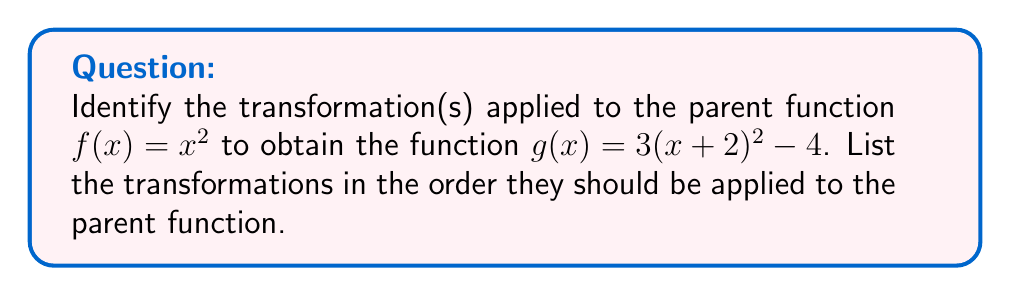Help me with this question. To identify the transformations applied to the parent function $f(x) = x^2$, we need to analyze the given function $g(x) = 3(x + 2)^2 - 4$ step by step:

1. First, let's rewrite the function in a standard form:
   $g(x) = 3(x + 2)^2 - 4$

2. Now, let's identify each transformation:

   a) Inside the parentheses, we see $(x + 2)$. This represents a horizontal shift 2 units to the left.
   
   b) The entire $(x + 2)^2$ is multiplied by 3. This represents a vertical stretch by a factor of 3.
   
   c) The entire expression is subtracted by 4. This represents a vertical shift 4 units down.

3. To apply these transformations to the parent function $f(x) = x^2$, we need to do them in the correct order:

   a) First, shift horizontally: $f(x + 2)$
   
   b) Then, stretch vertically: $3f(x + 2)$
   
   c) Finally, shift vertically: $3f(x + 2) - 4$

Therefore, the transformations in the correct order of application are:
1. Horizontal shift 2 units left
2. Vertical stretch by a factor of 3
3. Vertical shift 4 units down
Answer: The transformations applied to $f(x) = x^2$ to obtain $g(x) = 3(x + 2)^2 - 4$ are:
1. Horizontal shift 2 units left
2. Vertical stretch by a factor of 3
3. Vertical shift 4 units down 